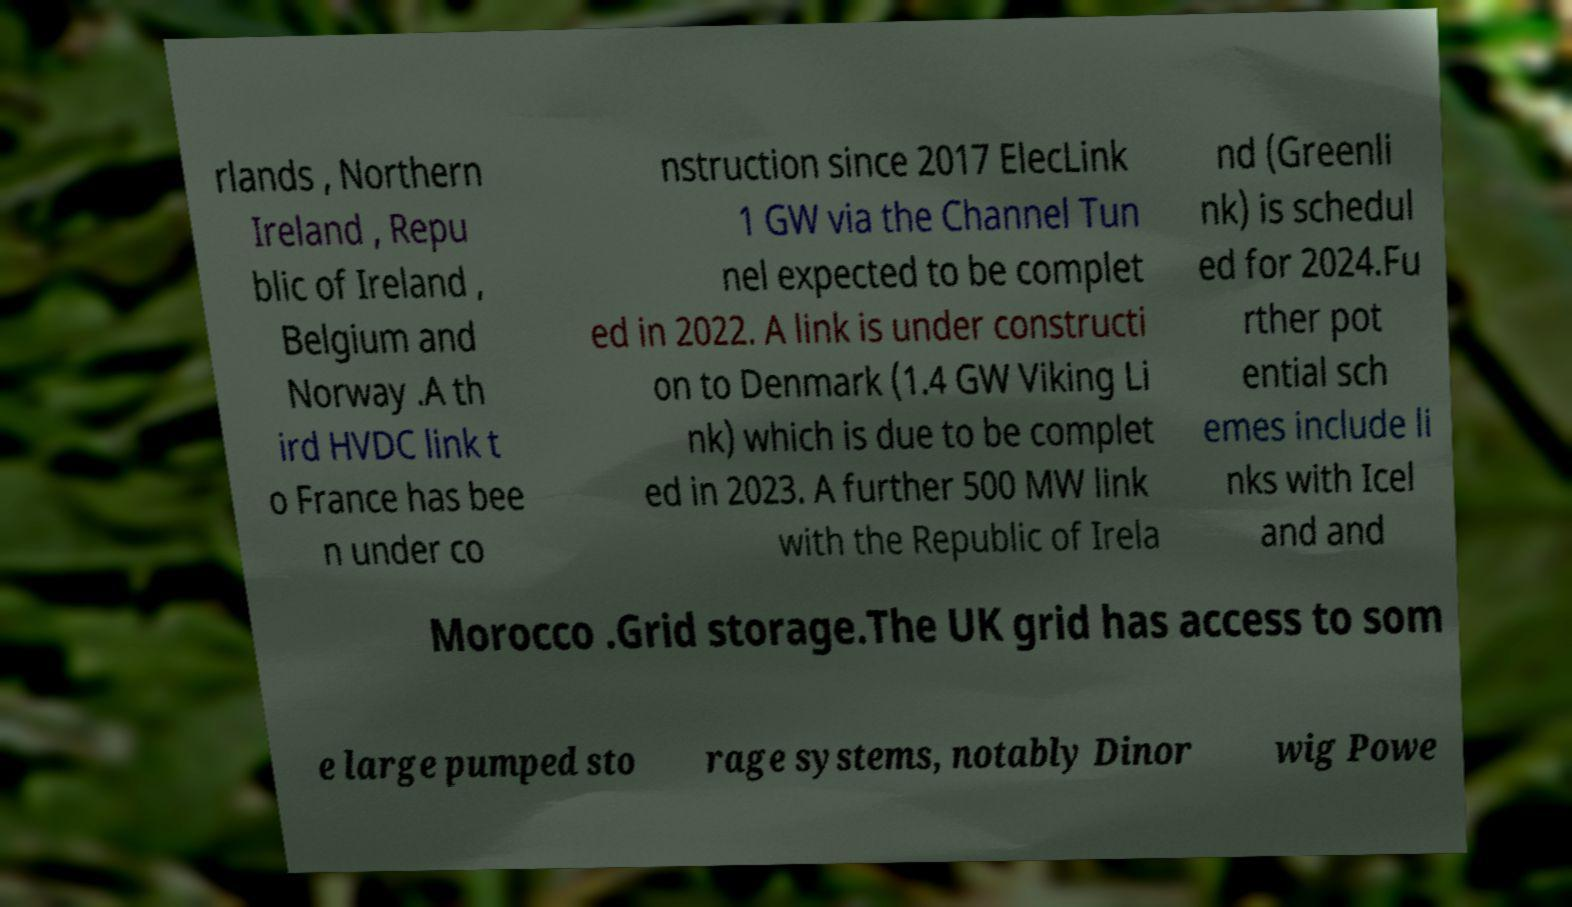Could you assist in decoding the text presented in this image and type it out clearly? rlands , Northern Ireland , Repu blic of Ireland , Belgium and Norway .A th ird HVDC link t o France has bee n under co nstruction since 2017 ElecLink 1 GW via the Channel Tun nel expected to be complet ed in 2022. A link is under constructi on to Denmark (1.4 GW Viking Li nk) which is due to be complet ed in 2023. A further 500 MW link with the Republic of Irela nd (Greenli nk) is schedul ed for 2024.Fu rther pot ential sch emes include li nks with Icel and and Morocco .Grid storage.The UK grid has access to som e large pumped sto rage systems, notably Dinor wig Powe 